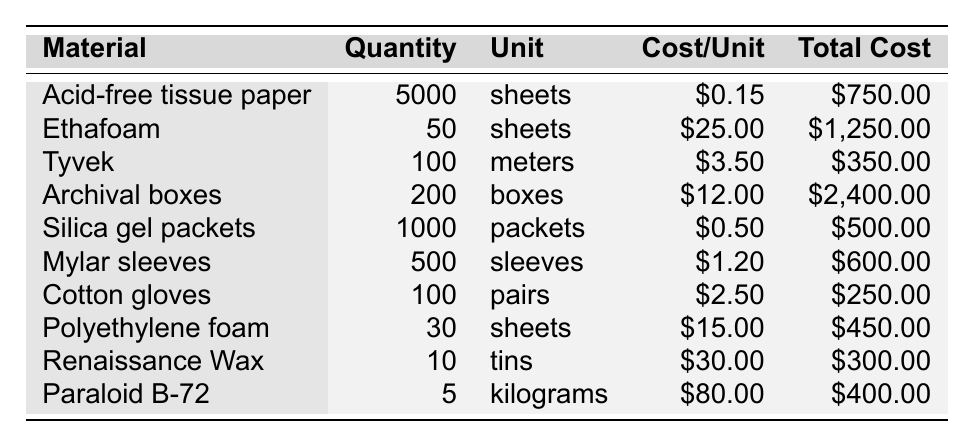What is the total cost of all conservation materials? To find the total cost of all conservation materials, we sum the total costs of each material: \$750.00 + \$1,250.00 + \$350.00 + \$2,400.00 + \$500.00 + \$600.00 + \$250.00 + \$450.00 + \$300.00 + \$400.00 = \$7,250.00.
Answer: $7,250.00 How many sheets of acid-free tissue paper are in inventory? The inventory specifies 5000 sheets of acid-free tissue paper, as listed under the appropriate column.
Answer: 5000 sheets What is the cost per unit for Tyvek? The cost per unit for Tyvek is given as \$3.50 in the cost per unit column.
Answer: $3.50 Is the total cost of archival boxes greater than that of Ethafoam? The total cost of archival boxes is \$2,400.00 and Ethafoam is \$1,250.00. Since \$2,400.00 is greater than \$1,250.00, the statement is true.
Answer: Yes How many more packets of silica gel are there than tints of Renaissance Wax? There are 1000 packets of silica gel and 10 tins of Renaissance Wax. The difference is calculated as 1000 - 10 = 990.
Answer: 990 What is the average cost per unit of the conservation materials listed? To find the average cost per unit, sum all the cost per unit values: \$0.15 + \$25.00 + \$3.50 + \$12.00 + \$0.50 + \$1.20 + \$2.50 + \$15.00 + \$30.00 + \$80.00 = \$169.85. There are 10 materials, so the average cost per unit is \$169.85 / 10 = \$16.985.
Answer: $16.99 Which material has the highest quantity in inventory? By inspecting the quantity column, acid-free tissue paper has the highest quantity at 5000 sheets.
Answer: Acid-free tissue paper How much does all the cotton gloves cost compared to the total cost of Paraloid B-72? The total cost for cotton gloves is \$250.00 and for Paraloid B-72 is \$400.00. Since \$250.00 is less than \$400.00, the total cost of cotton gloves is less.
Answer: Less What is the combined total cost of Mylar sleeves and Polyethylene foam? To find the combined cost, add the total costs of Mylar sleeves (\$600.00) and Polyethylene foam (\$450.00). Total is \$600.00 + \$450.00 = \$1,050.00.
Answer: $1,050.00 Do we have more than 200 boxes of archival boxes? The table shows we have 200 archival boxes, which means we do not have more than that number.
Answer: No 